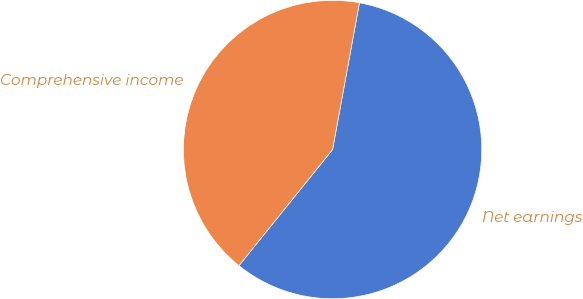Convert chart to OTSL. <chart><loc_0><loc_0><loc_500><loc_500><pie_chart><fcel>Net earnings<fcel>Comprehensive income<nl><fcel>57.92%<fcel>42.08%<nl></chart> 